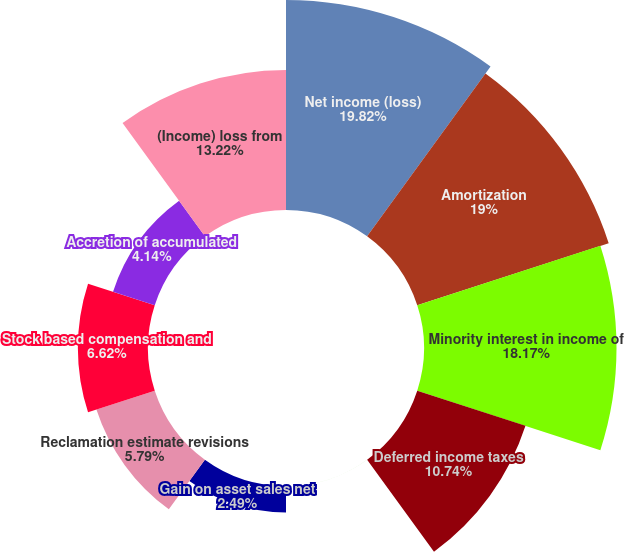Convert chart to OTSL. <chart><loc_0><loc_0><loc_500><loc_500><pie_chart><fcel>Net income (loss)<fcel>Amortization<fcel>Minority interest in income of<fcel>Deferred income taxes<fcel>Write-down of property plant<fcel>Gain on asset sales net<fcel>Reclamation estimate revisions<fcel>Stock based compensation and<fcel>Accretion of accumulated<fcel>(Income) loss from<nl><fcel>19.82%<fcel>19.0%<fcel>18.17%<fcel>10.74%<fcel>0.01%<fcel>2.49%<fcel>5.79%<fcel>6.62%<fcel>4.14%<fcel>13.22%<nl></chart> 